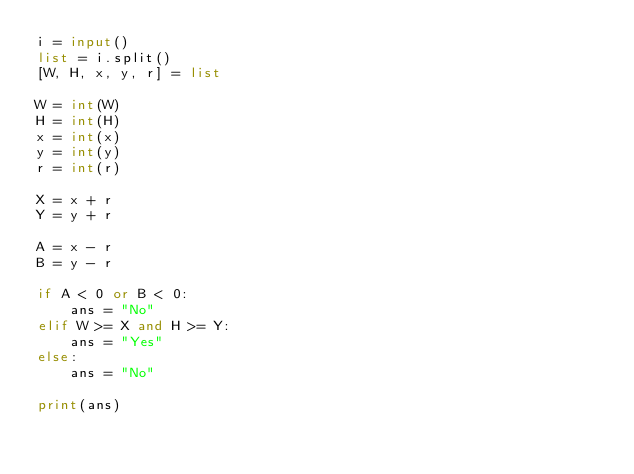Convert code to text. <code><loc_0><loc_0><loc_500><loc_500><_Python_>i = input()
list = i.split()
[W, H, x, y, r] = list

W = int(W)
H = int(H)
x = int(x)
y = int(y)
r = int(r)

X = x + r
Y = y + r

A = x - r
B = y - r

if A < 0 or B < 0:
    ans = "No"
elif W >= X and H >= Y:
    ans = "Yes"
else:
    ans = "No"

print(ans)
</code> 